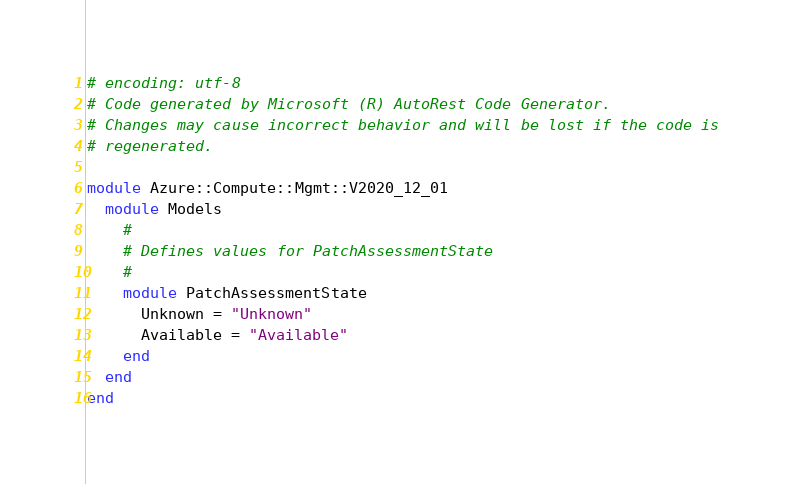<code> <loc_0><loc_0><loc_500><loc_500><_Ruby_># encoding: utf-8
# Code generated by Microsoft (R) AutoRest Code Generator.
# Changes may cause incorrect behavior and will be lost if the code is
# regenerated.

module Azure::Compute::Mgmt::V2020_12_01
  module Models
    #
    # Defines values for PatchAssessmentState
    #
    module PatchAssessmentState
      Unknown = "Unknown"
      Available = "Available"
    end
  end
end
</code> 